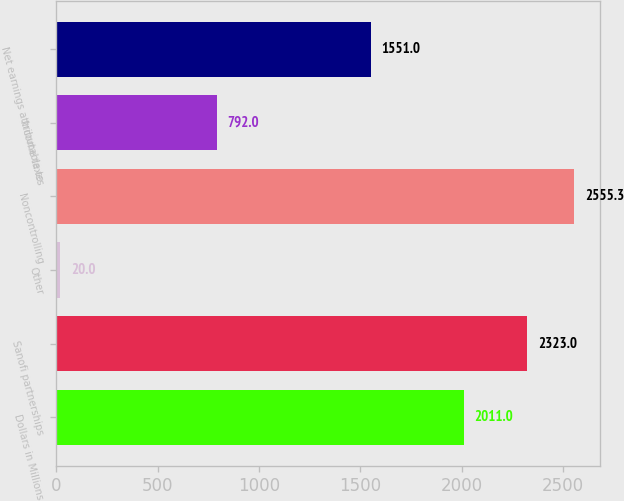<chart> <loc_0><loc_0><loc_500><loc_500><bar_chart><fcel>Dollars in Millions<fcel>Sanofi partnerships<fcel>Other<fcel>Noncontrolling<fcel>Income taxes<fcel>Net earnings attributable to<nl><fcel>2011<fcel>2323<fcel>20<fcel>2555.3<fcel>792<fcel>1551<nl></chart> 